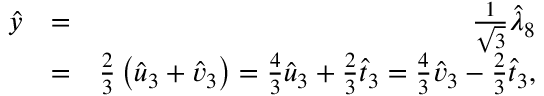<formula> <loc_0><loc_0><loc_500><loc_500>\begin{array} { r l r } { \hat { y } } & { = } & { \frac { 1 } { \sqrt { 3 } } \hat { \lambda } _ { 8 } } \\ & { = } & { \frac { 2 } { 3 } \left ( \hat { u } _ { 3 } + \hat { v } _ { 3 } \right ) = \frac { 4 } { 3 } \hat { u } _ { 3 } + \frac { 2 } { 3 } \hat { t } _ { 3 } = \frac { 4 } { 3 } \hat { v } _ { 3 } - \frac { 2 } { 3 } \hat { t } _ { 3 } , } \end{array}</formula> 